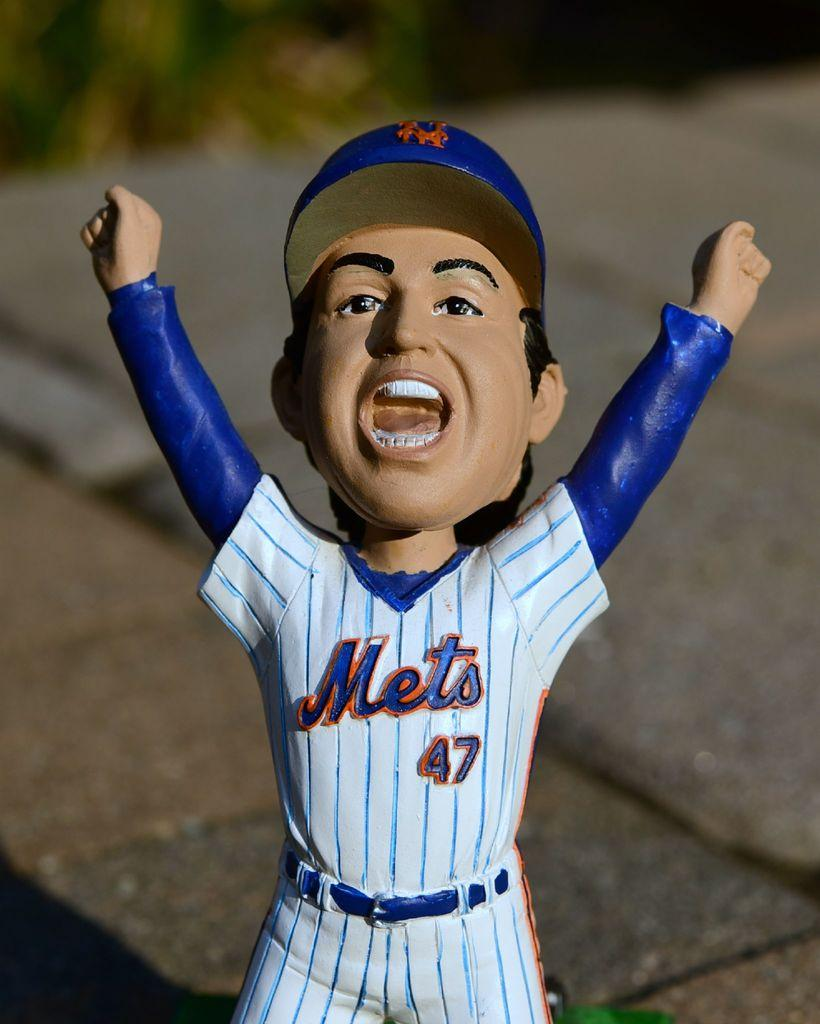<image>
Write a terse but informative summary of the picture. A Mets doll with the number 47 on it. 